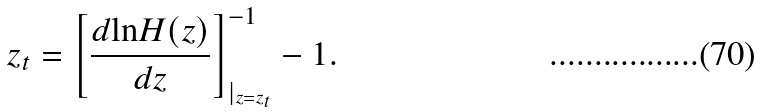Convert formula to latex. <formula><loc_0><loc_0><loc_500><loc_500>z _ { t } = \left [ \frac { d { \ln } H ( z ) } { d z } \right ] ^ { - 1 } _ { | _ { z = z _ { t } } } - 1 .</formula> 